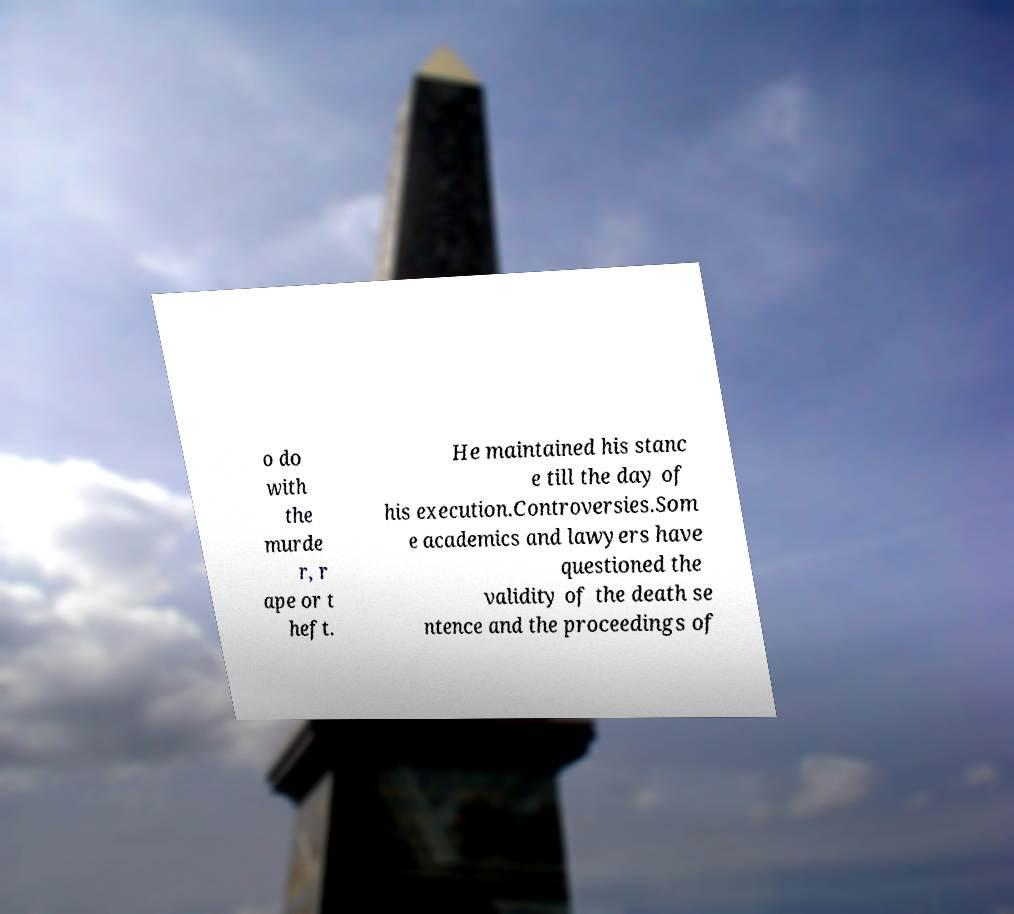Please read and relay the text visible in this image. What does it say? o do with the murde r, r ape or t heft. He maintained his stanc e till the day of his execution.Controversies.Som e academics and lawyers have questioned the validity of the death se ntence and the proceedings of 